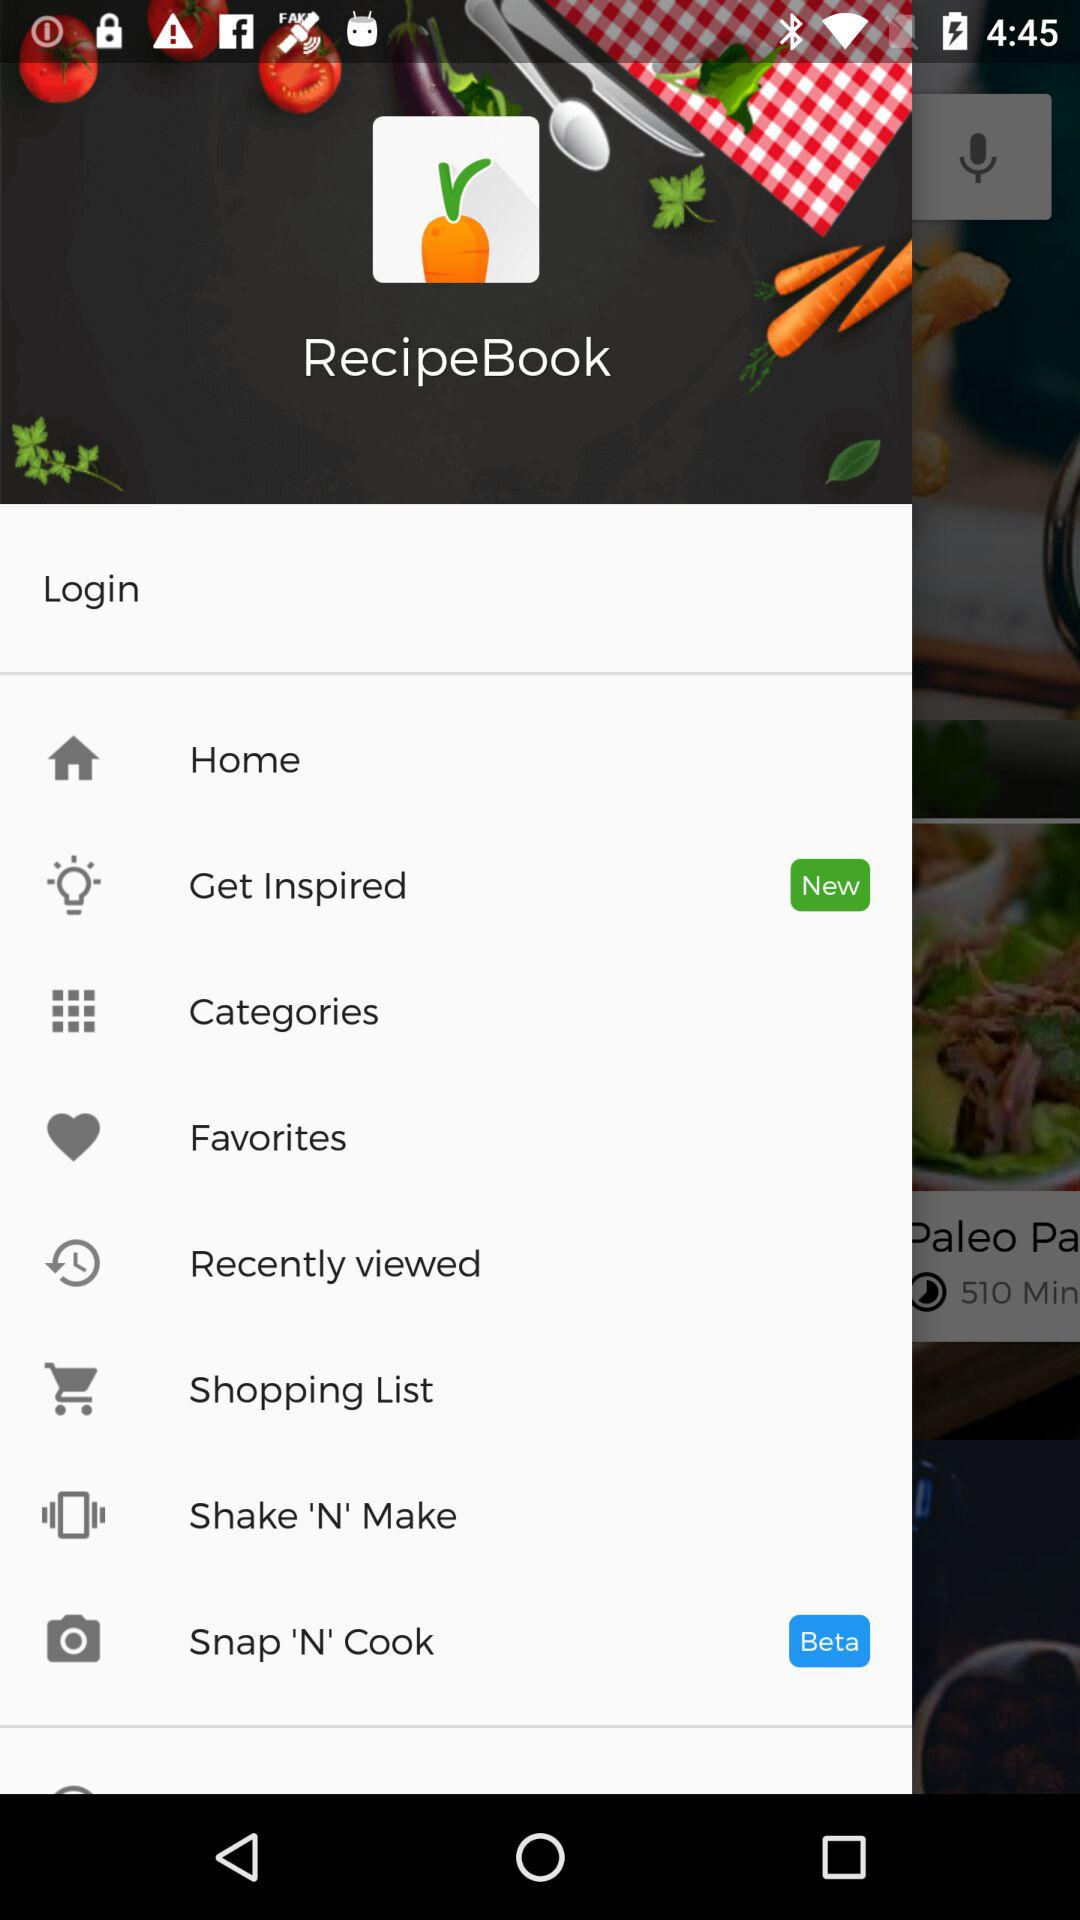What is the application name? The application name is "RecipeBook". 